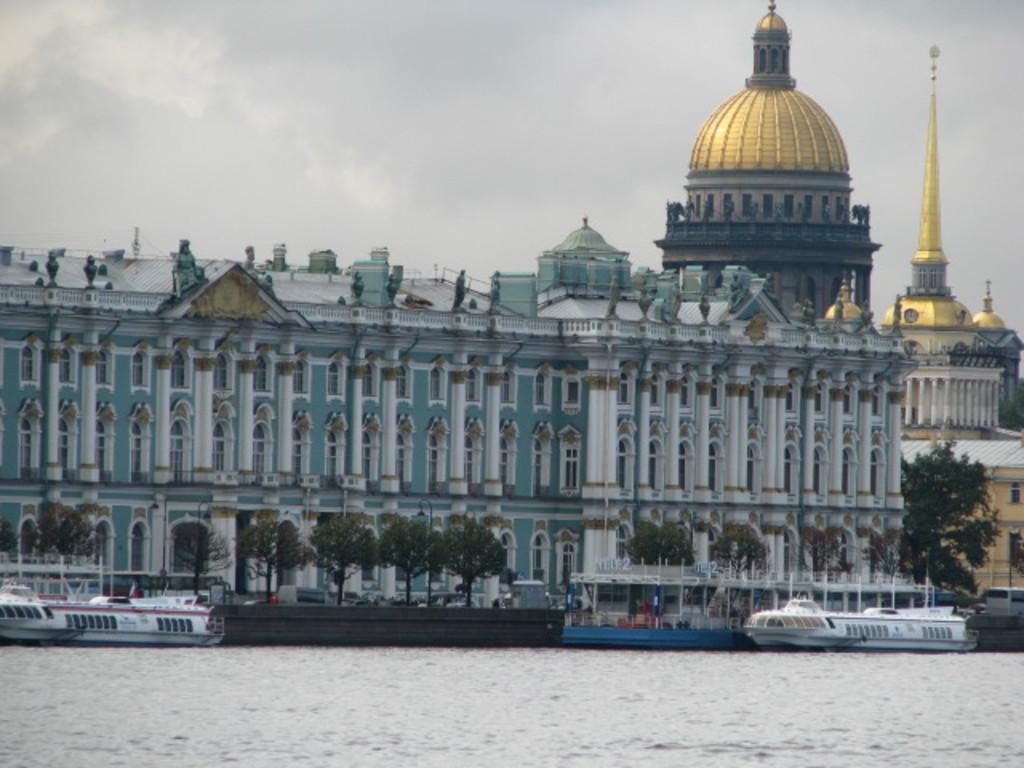Can you describe this image briefly? In this image we can see a few ships on the water, there are some buildings, windows, trees, flags and poles, in the background we can see the sky. 